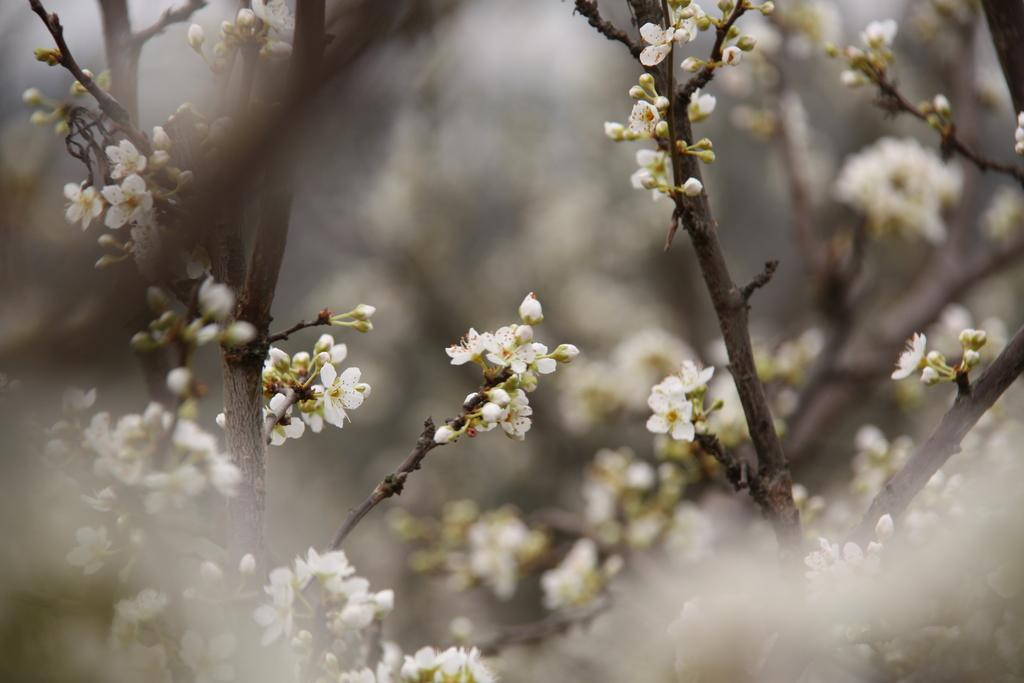What type of living organisms can be seen in the image? There are flowers, buds, and plants visible in the image. What stage of growth are some of the plants in the image? Some of the plants in the image have buds, indicating they are in the early stages of growth. What is the background of the image like? The background of the image is blurred. What type of border can be seen around the flowers in the image? There is no border visible around the flowers in the image. What sound can be heard coming from the plants in the image? There is no sound present in the image, as it is a still photograph. 